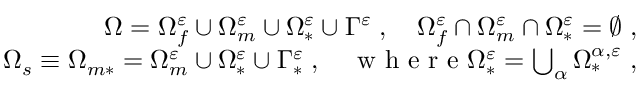Convert formula to latex. <formula><loc_0><loc_0><loc_500><loc_500>\begin{array} { r } { \Omega = \Omega _ { f } ^ { \varepsilon } \cup \Omega _ { m } ^ { \varepsilon } \cup \Omega _ { * } ^ { \varepsilon } \cup \Gamma ^ { \varepsilon } \, , \quad \Omega _ { f } ^ { \varepsilon } \cap \Omega _ { m } ^ { \varepsilon } \cap \Omega _ { * } ^ { \varepsilon } = \emptyset \, , } \\ { \Omega _ { s } \equiv \Omega _ { m * } = \Omega _ { m } ^ { \varepsilon } \cup \Omega _ { * } ^ { \varepsilon } \cup \Gamma _ { * } ^ { \varepsilon } \, , \quad w h e r e \Omega _ { * } ^ { \varepsilon } = \bigcup _ { \alpha } \Omega _ { * } ^ { { \alpha } , \varepsilon } \, , } \end{array}</formula> 